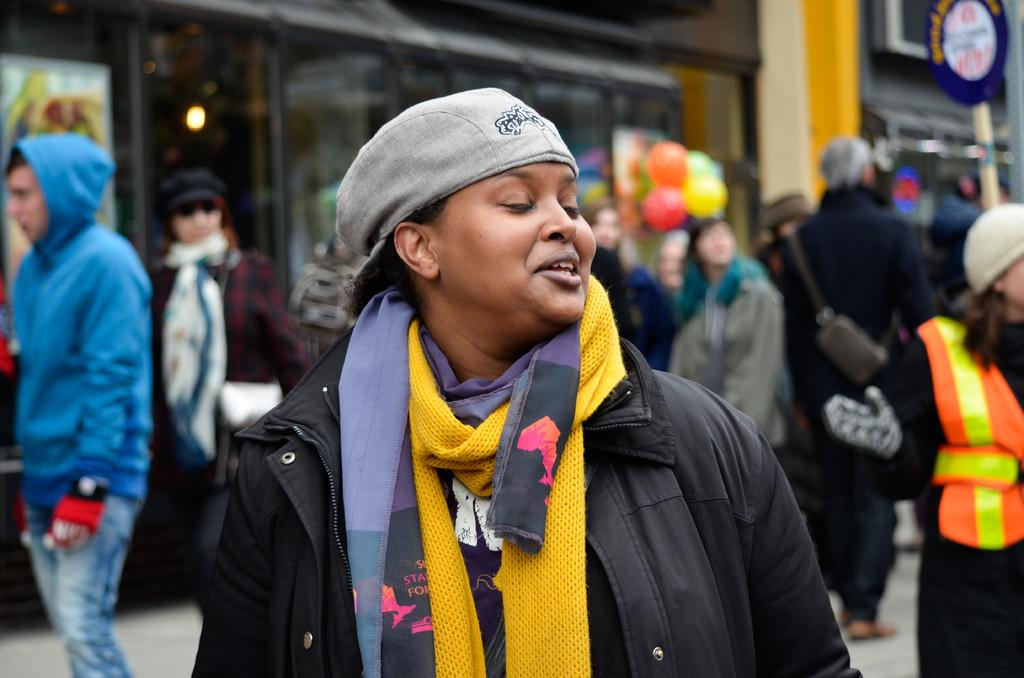Who is the main subject in the image? There is a woman in the center of the image. What is the woman wearing? The woman is wearing a jacket. What can be seen in the background of the image? There are people and a building in the background of the image. How many teeth can be seen in the woman's smile in the image? There is no indication of the woman smiling in the image, and even if she were, we cannot determine the number of teeth visible from the image. 